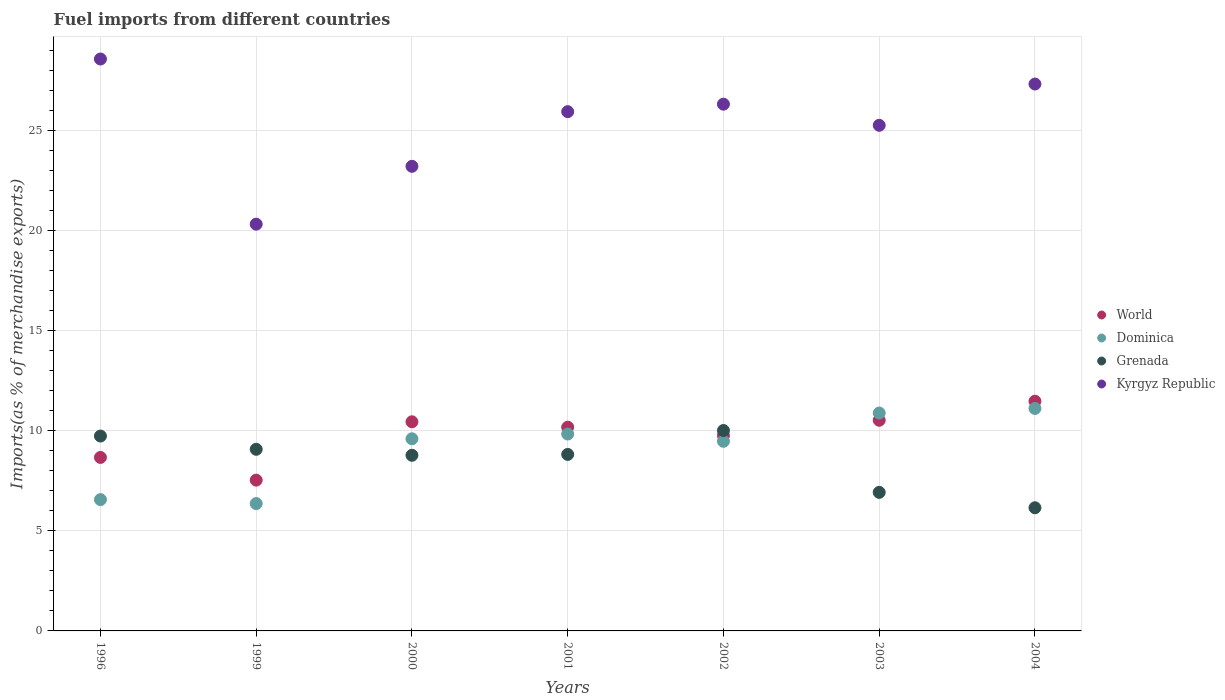Is the number of dotlines equal to the number of legend labels?
Provide a short and direct response. Yes. What is the percentage of imports to different countries in Dominica in 1996?
Provide a succinct answer. 6.56. Across all years, what is the maximum percentage of imports to different countries in World?
Your answer should be compact. 11.48. Across all years, what is the minimum percentage of imports to different countries in Grenada?
Offer a terse response. 6.15. In which year was the percentage of imports to different countries in Dominica minimum?
Give a very brief answer. 1999. What is the total percentage of imports to different countries in World in the graph?
Keep it short and to the point. 68.59. What is the difference between the percentage of imports to different countries in Kyrgyz Republic in 2001 and that in 2002?
Provide a succinct answer. -0.37. What is the difference between the percentage of imports to different countries in Kyrgyz Republic in 2003 and the percentage of imports to different countries in Grenada in 2001?
Offer a very short reply. 16.44. What is the average percentage of imports to different countries in Kyrgyz Republic per year?
Keep it short and to the point. 25.28. In the year 2001, what is the difference between the percentage of imports to different countries in Kyrgyz Republic and percentage of imports to different countries in World?
Give a very brief answer. 15.76. In how many years, is the percentage of imports to different countries in Kyrgyz Republic greater than 16 %?
Your answer should be compact. 7. What is the ratio of the percentage of imports to different countries in Dominica in 2001 to that in 2004?
Your answer should be compact. 0.89. What is the difference between the highest and the second highest percentage of imports to different countries in Kyrgyz Republic?
Give a very brief answer. 1.25. What is the difference between the highest and the lowest percentage of imports to different countries in World?
Give a very brief answer. 3.94. In how many years, is the percentage of imports to different countries in Dominica greater than the average percentage of imports to different countries in Dominica taken over all years?
Offer a very short reply. 5. Is it the case that in every year, the sum of the percentage of imports to different countries in Kyrgyz Republic and percentage of imports to different countries in World  is greater than the sum of percentage of imports to different countries in Dominica and percentage of imports to different countries in Grenada?
Offer a very short reply. Yes. Is it the case that in every year, the sum of the percentage of imports to different countries in Dominica and percentage of imports to different countries in Grenada  is greater than the percentage of imports to different countries in Kyrgyz Republic?
Make the answer very short. No. How many dotlines are there?
Keep it short and to the point. 4. How many years are there in the graph?
Provide a short and direct response. 7. Are the values on the major ticks of Y-axis written in scientific E-notation?
Provide a short and direct response. No. How many legend labels are there?
Your response must be concise. 4. What is the title of the graph?
Provide a succinct answer. Fuel imports from different countries. What is the label or title of the X-axis?
Make the answer very short. Years. What is the label or title of the Y-axis?
Keep it short and to the point. Imports(as % of merchandise exports). What is the Imports(as % of merchandise exports) in World in 1996?
Keep it short and to the point. 8.67. What is the Imports(as % of merchandise exports) in Dominica in 1996?
Your answer should be very brief. 6.56. What is the Imports(as % of merchandise exports) in Grenada in 1996?
Keep it short and to the point. 9.74. What is the Imports(as % of merchandise exports) of Kyrgyz Republic in 1996?
Ensure brevity in your answer.  28.58. What is the Imports(as % of merchandise exports) of World in 1999?
Your response must be concise. 7.53. What is the Imports(as % of merchandise exports) in Dominica in 1999?
Your answer should be very brief. 6.36. What is the Imports(as % of merchandise exports) of Grenada in 1999?
Provide a succinct answer. 9.08. What is the Imports(as % of merchandise exports) of Kyrgyz Republic in 1999?
Keep it short and to the point. 20.32. What is the Imports(as % of merchandise exports) in World in 2000?
Your answer should be compact. 10.45. What is the Imports(as % of merchandise exports) of Dominica in 2000?
Give a very brief answer. 9.6. What is the Imports(as % of merchandise exports) in Grenada in 2000?
Make the answer very short. 8.78. What is the Imports(as % of merchandise exports) of Kyrgyz Republic in 2000?
Offer a very short reply. 23.21. What is the Imports(as % of merchandise exports) of World in 2001?
Offer a terse response. 10.18. What is the Imports(as % of merchandise exports) in Dominica in 2001?
Offer a very short reply. 9.84. What is the Imports(as % of merchandise exports) in Grenada in 2001?
Give a very brief answer. 8.82. What is the Imports(as % of merchandise exports) of Kyrgyz Republic in 2001?
Your answer should be compact. 25.94. What is the Imports(as % of merchandise exports) in World in 2002?
Give a very brief answer. 9.76. What is the Imports(as % of merchandise exports) in Dominica in 2002?
Offer a very short reply. 9.48. What is the Imports(as % of merchandise exports) in Grenada in 2002?
Provide a short and direct response. 10.01. What is the Imports(as % of merchandise exports) of Kyrgyz Republic in 2002?
Provide a short and direct response. 26.32. What is the Imports(as % of merchandise exports) in World in 2003?
Make the answer very short. 10.53. What is the Imports(as % of merchandise exports) of Dominica in 2003?
Provide a succinct answer. 10.89. What is the Imports(as % of merchandise exports) of Grenada in 2003?
Provide a succinct answer. 6.92. What is the Imports(as % of merchandise exports) in Kyrgyz Republic in 2003?
Provide a short and direct response. 25.26. What is the Imports(as % of merchandise exports) of World in 2004?
Your answer should be compact. 11.48. What is the Imports(as % of merchandise exports) in Dominica in 2004?
Your answer should be compact. 11.12. What is the Imports(as % of merchandise exports) of Grenada in 2004?
Ensure brevity in your answer.  6.15. What is the Imports(as % of merchandise exports) in Kyrgyz Republic in 2004?
Offer a terse response. 27.33. Across all years, what is the maximum Imports(as % of merchandise exports) of World?
Provide a short and direct response. 11.48. Across all years, what is the maximum Imports(as % of merchandise exports) of Dominica?
Provide a short and direct response. 11.12. Across all years, what is the maximum Imports(as % of merchandise exports) of Grenada?
Your answer should be compact. 10.01. Across all years, what is the maximum Imports(as % of merchandise exports) in Kyrgyz Republic?
Your answer should be very brief. 28.58. Across all years, what is the minimum Imports(as % of merchandise exports) of World?
Offer a terse response. 7.53. Across all years, what is the minimum Imports(as % of merchandise exports) of Dominica?
Your response must be concise. 6.36. Across all years, what is the minimum Imports(as % of merchandise exports) of Grenada?
Offer a terse response. 6.15. Across all years, what is the minimum Imports(as % of merchandise exports) of Kyrgyz Republic?
Make the answer very short. 20.32. What is the total Imports(as % of merchandise exports) of World in the graph?
Keep it short and to the point. 68.59. What is the total Imports(as % of merchandise exports) of Dominica in the graph?
Make the answer very short. 63.84. What is the total Imports(as % of merchandise exports) in Grenada in the graph?
Your answer should be very brief. 59.5. What is the total Imports(as % of merchandise exports) in Kyrgyz Republic in the graph?
Give a very brief answer. 176.96. What is the difference between the Imports(as % of merchandise exports) in World in 1996 and that in 1999?
Your answer should be very brief. 1.14. What is the difference between the Imports(as % of merchandise exports) in Dominica in 1996 and that in 1999?
Keep it short and to the point. 0.2. What is the difference between the Imports(as % of merchandise exports) of Grenada in 1996 and that in 1999?
Keep it short and to the point. 0.66. What is the difference between the Imports(as % of merchandise exports) of Kyrgyz Republic in 1996 and that in 1999?
Your response must be concise. 8.25. What is the difference between the Imports(as % of merchandise exports) in World in 1996 and that in 2000?
Ensure brevity in your answer.  -1.78. What is the difference between the Imports(as % of merchandise exports) of Dominica in 1996 and that in 2000?
Your response must be concise. -3.04. What is the difference between the Imports(as % of merchandise exports) of Grenada in 1996 and that in 2000?
Your response must be concise. 0.96. What is the difference between the Imports(as % of merchandise exports) of Kyrgyz Republic in 1996 and that in 2000?
Make the answer very short. 5.36. What is the difference between the Imports(as % of merchandise exports) of World in 1996 and that in 2001?
Offer a very short reply. -1.51. What is the difference between the Imports(as % of merchandise exports) of Dominica in 1996 and that in 2001?
Make the answer very short. -3.28. What is the difference between the Imports(as % of merchandise exports) of Grenada in 1996 and that in 2001?
Your response must be concise. 0.92. What is the difference between the Imports(as % of merchandise exports) of Kyrgyz Republic in 1996 and that in 2001?
Make the answer very short. 2.63. What is the difference between the Imports(as % of merchandise exports) of World in 1996 and that in 2002?
Your response must be concise. -1.09. What is the difference between the Imports(as % of merchandise exports) of Dominica in 1996 and that in 2002?
Your answer should be compact. -2.92. What is the difference between the Imports(as % of merchandise exports) in Grenada in 1996 and that in 2002?
Your response must be concise. -0.28. What is the difference between the Imports(as % of merchandise exports) in Kyrgyz Republic in 1996 and that in 2002?
Provide a succinct answer. 2.26. What is the difference between the Imports(as % of merchandise exports) of World in 1996 and that in 2003?
Offer a very short reply. -1.86. What is the difference between the Imports(as % of merchandise exports) in Dominica in 1996 and that in 2003?
Ensure brevity in your answer.  -4.33. What is the difference between the Imports(as % of merchandise exports) of Grenada in 1996 and that in 2003?
Your answer should be very brief. 2.81. What is the difference between the Imports(as % of merchandise exports) of Kyrgyz Republic in 1996 and that in 2003?
Your answer should be compact. 3.31. What is the difference between the Imports(as % of merchandise exports) in World in 1996 and that in 2004?
Provide a succinct answer. -2.81. What is the difference between the Imports(as % of merchandise exports) of Dominica in 1996 and that in 2004?
Make the answer very short. -4.56. What is the difference between the Imports(as % of merchandise exports) of Grenada in 1996 and that in 2004?
Ensure brevity in your answer.  3.58. What is the difference between the Imports(as % of merchandise exports) in Kyrgyz Republic in 1996 and that in 2004?
Your answer should be very brief. 1.25. What is the difference between the Imports(as % of merchandise exports) of World in 1999 and that in 2000?
Your answer should be compact. -2.91. What is the difference between the Imports(as % of merchandise exports) of Dominica in 1999 and that in 2000?
Provide a succinct answer. -3.24. What is the difference between the Imports(as % of merchandise exports) of Grenada in 1999 and that in 2000?
Offer a terse response. 0.3. What is the difference between the Imports(as % of merchandise exports) in Kyrgyz Republic in 1999 and that in 2000?
Your answer should be compact. -2.89. What is the difference between the Imports(as % of merchandise exports) of World in 1999 and that in 2001?
Ensure brevity in your answer.  -2.65. What is the difference between the Imports(as % of merchandise exports) of Dominica in 1999 and that in 2001?
Your answer should be compact. -3.47. What is the difference between the Imports(as % of merchandise exports) of Grenada in 1999 and that in 2001?
Give a very brief answer. 0.26. What is the difference between the Imports(as % of merchandise exports) in Kyrgyz Republic in 1999 and that in 2001?
Give a very brief answer. -5.62. What is the difference between the Imports(as % of merchandise exports) in World in 1999 and that in 2002?
Your response must be concise. -2.23. What is the difference between the Imports(as % of merchandise exports) of Dominica in 1999 and that in 2002?
Your answer should be very brief. -3.11. What is the difference between the Imports(as % of merchandise exports) in Grenada in 1999 and that in 2002?
Make the answer very short. -0.94. What is the difference between the Imports(as % of merchandise exports) of Kyrgyz Republic in 1999 and that in 2002?
Ensure brevity in your answer.  -6. What is the difference between the Imports(as % of merchandise exports) of World in 1999 and that in 2003?
Your response must be concise. -2.99. What is the difference between the Imports(as % of merchandise exports) in Dominica in 1999 and that in 2003?
Provide a short and direct response. -4.52. What is the difference between the Imports(as % of merchandise exports) of Grenada in 1999 and that in 2003?
Your answer should be very brief. 2.15. What is the difference between the Imports(as % of merchandise exports) in Kyrgyz Republic in 1999 and that in 2003?
Offer a terse response. -4.94. What is the difference between the Imports(as % of merchandise exports) in World in 1999 and that in 2004?
Give a very brief answer. -3.94. What is the difference between the Imports(as % of merchandise exports) of Dominica in 1999 and that in 2004?
Make the answer very short. -4.75. What is the difference between the Imports(as % of merchandise exports) in Grenada in 1999 and that in 2004?
Your answer should be very brief. 2.92. What is the difference between the Imports(as % of merchandise exports) in Kyrgyz Republic in 1999 and that in 2004?
Offer a very short reply. -7. What is the difference between the Imports(as % of merchandise exports) of World in 2000 and that in 2001?
Offer a very short reply. 0.27. What is the difference between the Imports(as % of merchandise exports) in Dominica in 2000 and that in 2001?
Keep it short and to the point. -0.24. What is the difference between the Imports(as % of merchandise exports) of Grenada in 2000 and that in 2001?
Make the answer very short. -0.04. What is the difference between the Imports(as % of merchandise exports) in Kyrgyz Republic in 2000 and that in 2001?
Keep it short and to the point. -2.73. What is the difference between the Imports(as % of merchandise exports) of World in 2000 and that in 2002?
Offer a terse response. 0.69. What is the difference between the Imports(as % of merchandise exports) in Dominica in 2000 and that in 2002?
Offer a terse response. 0.13. What is the difference between the Imports(as % of merchandise exports) of Grenada in 2000 and that in 2002?
Give a very brief answer. -1.24. What is the difference between the Imports(as % of merchandise exports) in Kyrgyz Republic in 2000 and that in 2002?
Your answer should be compact. -3.1. What is the difference between the Imports(as % of merchandise exports) of World in 2000 and that in 2003?
Give a very brief answer. -0.08. What is the difference between the Imports(as % of merchandise exports) of Dominica in 2000 and that in 2003?
Keep it short and to the point. -1.29. What is the difference between the Imports(as % of merchandise exports) in Grenada in 2000 and that in 2003?
Offer a terse response. 1.85. What is the difference between the Imports(as % of merchandise exports) of Kyrgyz Republic in 2000 and that in 2003?
Ensure brevity in your answer.  -2.05. What is the difference between the Imports(as % of merchandise exports) of World in 2000 and that in 2004?
Ensure brevity in your answer.  -1.03. What is the difference between the Imports(as % of merchandise exports) in Dominica in 2000 and that in 2004?
Offer a terse response. -1.52. What is the difference between the Imports(as % of merchandise exports) of Grenada in 2000 and that in 2004?
Make the answer very short. 2.62. What is the difference between the Imports(as % of merchandise exports) in Kyrgyz Republic in 2000 and that in 2004?
Offer a very short reply. -4.11. What is the difference between the Imports(as % of merchandise exports) of World in 2001 and that in 2002?
Your answer should be very brief. 0.42. What is the difference between the Imports(as % of merchandise exports) in Dominica in 2001 and that in 2002?
Provide a short and direct response. 0.36. What is the difference between the Imports(as % of merchandise exports) of Grenada in 2001 and that in 2002?
Keep it short and to the point. -1.19. What is the difference between the Imports(as % of merchandise exports) of Kyrgyz Republic in 2001 and that in 2002?
Offer a very short reply. -0.37. What is the difference between the Imports(as % of merchandise exports) of World in 2001 and that in 2003?
Provide a short and direct response. -0.35. What is the difference between the Imports(as % of merchandise exports) in Dominica in 2001 and that in 2003?
Offer a terse response. -1.05. What is the difference between the Imports(as % of merchandise exports) of Grenada in 2001 and that in 2003?
Offer a very short reply. 1.9. What is the difference between the Imports(as % of merchandise exports) in Kyrgyz Republic in 2001 and that in 2003?
Your answer should be compact. 0.68. What is the difference between the Imports(as % of merchandise exports) in World in 2001 and that in 2004?
Give a very brief answer. -1.3. What is the difference between the Imports(as % of merchandise exports) of Dominica in 2001 and that in 2004?
Make the answer very short. -1.28. What is the difference between the Imports(as % of merchandise exports) of Grenada in 2001 and that in 2004?
Your answer should be compact. 2.66. What is the difference between the Imports(as % of merchandise exports) in Kyrgyz Republic in 2001 and that in 2004?
Your answer should be very brief. -1.38. What is the difference between the Imports(as % of merchandise exports) of World in 2002 and that in 2003?
Make the answer very short. -0.77. What is the difference between the Imports(as % of merchandise exports) of Dominica in 2002 and that in 2003?
Offer a terse response. -1.41. What is the difference between the Imports(as % of merchandise exports) of Grenada in 2002 and that in 2003?
Your response must be concise. 3.09. What is the difference between the Imports(as % of merchandise exports) of Kyrgyz Republic in 2002 and that in 2003?
Your answer should be very brief. 1.06. What is the difference between the Imports(as % of merchandise exports) of World in 2002 and that in 2004?
Your answer should be very brief. -1.72. What is the difference between the Imports(as % of merchandise exports) in Dominica in 2002 and that in 2004?
Your answer should be very brief. -1.64. What is the difference between the Imports(as % of merchandise exports) in Grenada in 2002 and that in 2004?
Your response must be concise. 3.86. What is the difference between the Imports(as % of merchandise exports) of Kyrgyz Republic in 2002 and that in 2004?
Ensure brevity in your answer.  -1.01. What is the difference between the Imports(as % of merchandise exports) in World in 2003 and that in 2004?
Your answer should be very brief. -0.95. What is the difference between the Imports(as % of merchandise exports) in Dominica in 2003 and that in 2004?
Keep it short and to the point. -0.23. What is the difference between the Imports(as % of merchandise exports) in Grenada in 2003 and that in 2004?
Offer a terse response. 0.77. What is the difference between the Imports(as % of merchandise exports) in Kyrgyz Republic in 2003 and that in 2004?
Make the answer very short. -2.06. What is the difference between the Imports(as % of merchandise exports) in World in 1996 and the Imports(as % of merchandise exports) in Dominica in 1999?
Give a very brief answer. 2.31. What is the difference between the Imports(as % of merchandise exports) in World in 1996 and the Imports(as % of merchandise exports) in Grenada in 1999?
Offer a terse response. -0.41. What is the difference between the Imports(as % of merchandise exports) of World in 1996 and the Imports(as % of merchandise exports) of Kyrgyz Republic in 1999?
Make the answer very short. -11.65. What is the difference between the Imports(as % of merchandise exports) of Dominica in 1996 and the Imports(as % of merchandise exports) of Grenada in 1999?
Your response must be concise. -2.52. What is the difference between the Imports(as % of merchandise exports) of Dominica in 1996 and the Imports(as % of merchandise exports) of Kyrgyz Republic in 1999?
Offer a terse response. -13.76. What is the difference between the Imports(as % of merchandise exports) of Grenada in 1996 and the Imports(as % of merchandise exports) of Kyrgyz Republic in 1999?
Your answer should be compact. -10.59. What is the difference between the Imports(as % of merchandise exports) in World in 1996 and the Imports(as % of merchandise exports) in Dominica in 2000?
Keep it short and to the point. -0.93. What is the difference between the Imports(as % of merchandise exports) in World in 1996 and the Imports(as % of merchandise exports) in Grenada in 2000?
Ensure brevity in your answer.  -0.11. What is the difference between the Imports(as % of merchandise exports) of World in 1996 and the Imports(as % of merchandise exports) of Kyrgyz Republic in 2000?
Give a very brief answer. -14.54. What is the difference between the Imports(as % of merchandise exports) in Dominica in 1996 and the Imports(as % of merchandise exports) in Grenada in 2000?
Your answer should be compact. -2.22. What is the difference between the Imports(as % of merchandise exports) of Dominica in 1996 and the Imports(as % of merchandise exports) of Kyrgyz Republic in 2000?
Make the answer very short. -16.65. What is the difference between the Imports(as % of merchandise exports) of Grenada in 1996 and the Imports(as % of merchandise exports) of Kyrgyz Republic in 2000?
Offer a very short reply. -13.48. What is the difference between the Imports(as % of merchandise exports) in World in 1996 and the Imports(as % of merchandise exports) in Dominica in 2001?
Provide a succinct answer. -1.17. What is the difference between the Imports(as % of merchandise exports) in World in 1996 and the Imports(as % of merchandise exports) in Grenada in 2001?
Provide a short and direct response. -0.15. What is the difference between the Imports(as % of merchandise exports) in World in 1996 and the Imports(as % of merchandise exports) in Kyrgyz Republic in 2001?
Ensure brevity in your answer.  -17.28. What is the difference between the Imports(as % of merchandise exports) in Dominica in 1996 and the Imports(as % of merchandise exports) in Grenada in 2001?
Your response must be concise. -2.26. What is the difference between the Imports(as % of merchandise exports) of Dominica in 1996 and the Imports(as % of merchandise exports) of Kyrgyz Republic in 2001?
Keep it short and to the point. -19.38. What is the difference between the Imports(as % of merchandise exports) in Grenada in 1996 and the Imports(as % of merchandise exports) in Kyrgyz Republic in 2001?
Ensure brevity in your answer.  -16.21. What is the difference between the Imports(as % of merchandise exports) in World in 1996 and the Imports(as % of merchandise exports) in Dominica in 2002?
Make the answer very short. -0.81. What is the difference between the Imports(as % of merchandise exports) in World in 1996 and the Imports(as % of merchandise exports) in Grenada in 2002?
Make the answer very short. -1.34. What is the difference between the Imports(as % of merchandise exports) of World in 1996 and the Imports(as % of merchandise exports) of Kyrgyz Republic in 2002?
Your answer should be very brief. -17.65. What is the difference between the Imports(as % of merchandise exports) of Dominica in 1996 and the Imports(as % of merchandise exports) of Grenada in 2002?
Make the answer very short. -3.45. What is the difference between the Imports(as % of merchandise exports) in Dominica in 1996 and the Imports(as % of merchandise exports) in Kyrgyz Republic in 2002?
Give a very brief answer. -19.76. What is the difference between the Imports(as % of merchandise exports) of Grenada in 1996 and the Imports(as % of merchandise exports) of Kyrgyz Republic in 2002?
Ensure brevity in your answer.  -16.58. What is the difference between the Imports(as % of merchandise exports) of World in 1996 and the Imports(as % of merchandise exports) of Dominica in 2003?
Your answer should be compact. -2.22. What is the difference between the Imports(as % of merchandise exports) in World in 1996 and the Imports(as % of merchandise exports) in Grenada in 2003?
Make the answer very short. 1.75. What is the difference between the Imports(as % of merchandise exports) in World in 1996 and the Imports(as % of merchandise exports) in Kyrgyz Republic in 2003?
Provide a succinct answer. -16.59. What is the difference between the Imports(as % of merchandise exports) of Dominica in 1996 and the Imports(as % of merchandise exports) of Grenada in 2003?
Give a very brief answer. -0.36. What is the difference between the Imports(as % of merchandise exports) in Dominica in 1996 and the Imports(as % of merchandise exports) in Kyrgyz Republic in 2003?
Provide a succinct answer. -18.7. What is the difference between the Imports(as % of merchandise exports) of Grenada in 1996 and the Imports(as % of merchandise exports) of Kyrgyz Republic in 2003?
Make the answer very short. -15.53. What is the difference between the Imports(as % of merchandise exports) of World in 1996 and the Imports(as % of merchandise exports) of Dominica in 2004?
Offer a very short reply. -2.45. What is the difference between the Imports(as % of merchandise exports) in World in 1996 and the Imports(as % of merchandise exports) in Grenada in 2004?
Make the answer very short. 2.52. What is the difference between the Imports(as % of merchandise exports) in World in 1996 and the Imports(as % of merchandise exports) in Kyrgyz Republic in 2004?
Keep it short and to the point. -18.66. What is the difference between the Imports(as % of merchandise exports) in Dominica in 1996 and the Imports(as % of merchandise exports) in Grenada in 2004?
Offer a very short reply. 0.41. What is the difference between the Imports(as % of merchandise exports) of Dominica in 1996 and the Imports(as % of merchandise exports) of Kyrgyz Republic in 2004?
Provide a short and direct response. -20.77. What is the difference between the Imports(as % of merchandise exports) of Grenada in 1996 and the Imports(as % of merchandise exports) of Kyrgyz Republic in 2004?
Ensure brevity in your answer.  -17.59. What is the difference between the Imports(as % of merchandise exports) of World in 1999 and the Imports(as % of merchandise exports) of Dominica in 2000?
Offer a very short reply. -2.07. What is the difference between the Imports(as % of merchandise exports) in World in 1999 and the Imports(as % of merchandise exports) in Grenada in 2000?
Make the answer very short. -1.24. What is the difference between the Imports(as % of merchandise exports) of World in 1999 and the Imports(as % of merchandise exports) of Kyrgyz Republic in 2000?
Your response must be concise. -15.68. What is the difference between the Imports(as % of merchandise exports) in Dominica in 1999 and the Imports(as % of merchandise exports) in Grenada in 2000?
Provide a short and direct response. -2.41. What is the difference between the Imports(as % of merchandise exports) in Dominica in 1999 and the Imports(as % of merchandise exports) in Kyrgyz Republic in 2000?
Provide a short and direct response. -16.85. What is the difference between the Imports(as % of merchandise exports) in Grenada in 1999 and the Imports(as % of merchandise exports) in Kyrgyz Republic in 2000?
Offer a very short reply. -14.14. What is the difference between the Imports(as % of merchandise exports) of World in 1999 and the Imports(as % of merchandise exports) of Dominica in 2001?
Offer a very short reply. -2.3. What is the difference between the Imports(as % of merchandise exports) of World in 1999 and the Imports(as % of merchandise exports) of Grenada in 2001?
Your response must be concise. -1.28. What is the difference between the Imports(as % of merchandise exports) in World in 1999 and the Imports(as % of merchandise exports) in Kyrgyz Republic in 2001?
Make the answer very short. -18.41. What is the difference between the Imports(as % of merchandise exports) in Dominica in 1999 and the Imports(as % of merchandise exports) in Grenada in 2001?
Your answer should be compact. -2.46. What is the difference between the Imports(as % of merchandise exports) of Dominica in 1999 and the Imports(as % of merchandise exports) of Kyrgyz Republic in 2001?
Your answer should be very brief. -19.58. What is the difference between the Imports(as % of merchandise exports) in Grenada in 1999 and the Imports(as % of merchandise exports) in Kyrgyz Republic in 2001?
Give a very brief answer. -16.87. What is the difference between the Imports(as % of merchandise exports) of World in 1999 and the Imports(as % of merchandise exports) of Dominica in 2002?
Your answer should be compact. -1.94. What is the difference between the Imports(as % of merchandise exports) in World in 1999 and the Imports(as % of merchandise exports) in Grenada in 2002?
Keep it short and to the point. -2.48. What is the difference between the Imports(as % of merchandise exports) in World in 1999 and the Imports(as % of merchandise exports) in Kyrgyz Republic in 2002?
Make the answer very short. -18.79. What is the difference between the Imports(as % of merchandise exports) in Dominica in 1999 and the Imports(as % of merchandise exports) in Grenada in 2002?
Provide a succinct answer. -3.65. What is the difference between the Imports(as % of merchandise exports) of Dominica in 1999 and the Imports(as % of merchandise exports) of Kyrgyz Republic in 2002?
Provide a succinct answer. -19.96. What is the difference between the Imports(as % of merchandise exports) in Grenada in 1999 and the Imports(as % of merchandise exports) in Kyrgyz Republic in 2002?
Your answer should be compact. -17.24. What is the difference between the Imports(as % of merchandise exports) in World in 1999 and the Imports(as % of merchandise exports) in Dominica in 2003?
Your answer should be very brief. -3.35. What is the difference between the Imports(as % of merchandise exports) in World in 1999 and the Imports(as % of merchandise exports) in Grenada in 2003?
Offer a terse response. 0.61. What is the difference between the Imports(as % of merchandise exports) of World in 1999 and the Imports(as % of merchandise exports) of Kyrgyz Republic in 2003?
Make the answer very short. -17.73. What is the difference between the Imports(as % of merchandise exports) of Dominica in 1999 and the Imports(as % of merchandise exports) of Grenada in 2003?
Ensure brevity in your answer.  -0.56. What is the difference between the Imports(as % of merchandise exports) in Dominica in 1999 and the Imports(as % of merchandise exports) in Kyrgyz Republic in 2003?
Give a very brief answer. -18.9. What is the difference between the Imports(as % of merchandise exports) in Grenada in 1999 and the Imports(as % of merchandise exports) in Kyrgyz Republic in 2003?
Your answer should be very brief. -16.19. What is the difference between the Imports(as % of merchandise exports) in World in 1999 and the Imports(as % of merchandise exports) in Dominica in 2004?
Provide a succinct answer. -3.58. What is the difference between the Imports(as % of merchandise exports) in World in 1999 and the Imports(as % of merchandise exports) in Grenada in 2004?
Make the answer very short. 1.38. What is the difference between the Imports(as % of merchandise exports) in World in 1999 and the Imports(as % of merchandise exports) in Kyrgyz Republic in 2004?
Your response must be concise. -19.79. What is the difference between the Imports(as % of merchandise exports) in Dominica in 1999 and the Imports(as % of merchandise exports) in Grenada in 2004?
Provide a short and direct response. 0.21. What is the difference between the Imports(as % of merchandise exports) of Dominica in 1999 and the Imports(as % of merchandise exports) of Kyrgyz Republic in 2004?
Give a very brief answer. -20.96. What is the difference between the Imports(as % of merchandise exports) of Grenada in 1999 and the Imports(as % of merchandise exports) of Kyrgyz Republic in 2004?
Your response must be concise. -18.25. What is the difference between the Imports(as % of merchandise exports) of World in 2000 and the Imports(as % of merchandise exports) of Dominica in 2001?
Provide a succinct answer. 0.61. What is the difference between the Imports(as % of merchandise exports) in World in 2000 and the Imports(as % of merchandise exports) in Grenada in 2001?
Ensure brevity in your answer.  1.63. What is the difference between the Imports(as % of merchandise exports) of World in 2000 and the Imports(as % of merchandise exports) of Kyrgyz Republic in 2001?
Provide a short and direct response. -15.5. What is the difference between the Imports(as % of merchandise exports) in Dominica in 2000 and the Imports(as % of merchandise exports) in Grenada in 2001?
Give a very brief answer. 0.78. What is the difference between the Imports(as % of merchandise exports) of Dominica in 2000 and the Imports(as % of merchandise exports) of Kyrgyz Republic in 2001?
Offer a very short reply. -16.34. What is the difference between the Imports(as % of merchandise exports) in Grenada in 2000 and the Imports(as % of merchandise exports) in Kyrgyz Republic in 2001?
Give a very brief answer. -17.17. What is the difference between the Imports(as % of merchandise exports) in World in 2000 and the Imports(as % of merchandise exports) in Dominica in 2002?
Provide a short and direct response. 0.97. What is the difference between the Imports(as % of merchandise exports) in World in 2000 and the Imports(as % of merchandise exports) in Grenada in 2002?
Ensure brevity in your answer.  0.43. What is the difference between the Imports(as % of merchandise exports) of World in 2000 and the Imports(as % of merchandise exports) of Kyrgyz Republic in 2002?
Your answer should be very brief. -15.87. What is the difference between the Imports(as % of merchandise exports) of Dominica in 2000 and the Imports(as % of merchandise exports) of Grenada in 2002?
Provide a succinct answer. -0.41. What is the difference between the Imports(as % of merchandise exports) in Dominica in 2000 and the Imports(as % of merchandise exports) in Kyrgyz Republic in 2002?
Offer a terse response. -16.72. What is the difference between the Imports(as % of merchandise exports) of Grenada in 2000 and the Imports(as % of merchandise exports) of Kyrgyz Republic in 2002?
Offer a terse response. -17.54. What is the difference between the Imports(as % of merchandise exports) of World in 2000 and the Imports(as % of merchandise exports) of Dominica in 2003?
Offer a terse response. -0.44. What is the difference between the Imports(as % of merchandise exports) of World in 2000 and the Imports(as % of merchandise exports) of Grenada in 2003?
Keep it short and to the point. 3.53. What is the difference between the Imports(as % of merchandise exports) of World in 2000 and the Imports(as % of merchandise exports) of Kyrgyz Republic in 2003?
Ensure brevity in your answer.  -14.81. What is the difference between the Imports(as % of merchandise exports) of Dominica in 2000 and the Imports(as % of merchandise exports) of Grenada in 2003?
Offer a terse response. 2.68. What is the difference between the Imports(as % of merchandise exports) in Dominica in 2000 and the Imports(as % of merchandise exports) in Kyrgyz Republic in 2003?
Your answer should be compact. -15.66. What is the difference between the Imports(as % of merchandise exports) in Grenada in 2000 and the Imports(as % of merchandise exports) in Kyrgyz Republic in 2003?
Provide a short and direct response. -16.49. What is the difference between the Imports(as % of merchandise exports) in World in 2000 and the Imports(as % of merchandise exports) in Dominica in 2004?
Offer a terse response. -0.67. What is the difference between the Imports(as % of merchandise exports) in World in 2000 and the Imports(as % of merchandise exports) in Grenada in 2004?
Your answer should be very brief. 4.29. What is the difference between the Imports(as % of merchandise exports) in World in 2000 and the Imports(as % of merchandise exports) in Kyrgyz Republic in 2004?
Offer a terse response. -16.88. What is the difference between the Imports(as % of merchandise exports) in Dominica in 2000 and the Imports(as % of merchandise exports) in Grenada in 2004?
Your response must be concise. 3.45. What is the difference between the Imports(as % of merchandise exports) of Dominica in 2000 and the Imports(as % of merchandise exports) of Kyrgyz Republic in 2004?
Offer a terse response. -17.73. What is the difference between the Imports(as % of merchandise exports) in Grenada in 2000 and the Imports(as % of merchandise exports) in Kyrgyz Republic in 2004?
Provide a succinct answer. -18.55. What is the difference between the Imports(as % of merchandise exports) of World in 2001 and the Imports(as % of merchandise exports) of Dominica in 2002?
Offer a terse response. 0.7. What is the difference between the Imports(as % of merchandise exports) of World in 2001 and the Imports(as % of merchandise exports) of Grenada in 2002?
Provide a short and direct response. 0.17. What is the difference between the Imports(as % of merchandise exports) in World in 2001 and the Imports(as % of merchandise exports) in Kyrgyz Republic in 2002?
Provide a short and direct response. -16.14. What is the difference between the Imports(as % of merchandise exports) of Dominica in 2001 and the Imports(as % of merchandise exports) of Grenada in 2002?
Your answer should be very brief. -0.18. What is the difference between the Imports(as % of merchandise exports) in Dominica in 2001 and the Imports(as % of merchandise exports) in Kyrgyz Republic in 2002?
Offer a terse response. -16.48. What is the difference between the Imports(as % of merchandise exports) in Grenada in 2001 and the Imports(as % of merchandise exports) in Kyrgyz Republic in 2002?
Offer a terse response. -17.5. What is the difference between the Imports(as % of merchandise exports) in World in 2001 and the Imports(as % of merchandise exports) in Dominica in 2003?
Offer a terse response. -0.71. What is the difference between the Imports(as % of merchandise exports) of World in 2001 and the Imports(as % of merchandise exports) of Grenada in 2003?
Offer a very short reply. 3.26. What is the difference between the Imports(as % of merchandise exports) of World in 2001 and the Imports(as % of merchandise exports) of Kyrgyz Republic in 2003?
Ensure brevity in your answer.  -15.08. What is the difference between the Imports(as % of merchandise exports) in Dominica in 2001 and the Imports(as % of merchandise exports) in Grenada in 2003?
Your response must be concise. 2.91. What is the difference between the Imports(as % of merchandise exports) of Dominica in 2001 and the Imports(as % of merchandise exports) of Kyrgyz Republic in 2003?
Provide a succinct answer. -15.43. What is the difference between the Imports(as % of merchandise exports) of Grenada in 2001 and the Imports(as % of merchandise exports) of Kyrgyz Republic in 2003?
Offer a very short reply. -16.44. What is the difference between the Imports(as % of merchandise exports) in World in 2001 and the Imports(as % of merchandise exports) in Dominica in 2004?
Provide a short and direct response. -0.94. What is the difference between the Imports(as % of merchandise exports) in World in 2001 and the Imports(as % of merchandise exports) in Grenada in 2004?
Your answer should be compact. 4.03. What is the difference between the Imports(as % of merchandise exports) in World in 2001 and the Imports(as % of merchandise exports) in Kyrgyz Republic in 2004?
Offer a terse response. -17.15. What is the difference between the Imports(as % of merchandise exports) in Dominica in 2001 and the Imports(as % of merchandise exports) in Grenada in 2004?
Your response must be concise. 3.68. What is the difference between the Imports(as % of merchandise exports) of Dominica in 2001 and the Imports(as % of merchandise exports) of Kyrgyz Republic in 2004?
Make the answer very short. -17.49. What is the difference between the Imports(as % of merchandise exports) in Grenada in 2001 and the Imports(as % of merchandise exports) in Kyrgyz Republic in 2004?
Provide a succinct answer. -18.51. What is the difference between the Imports(as % of merchandise exports) in World in 2002 and the Imports(as % of merchandise exports) in Dominica in 2003?
Offer a terse response. -1.13. What is the difference between the Imports(as % of merchandise exports) of World in 2002 and the Imports(as % of merchandise exports) of Grenada in 2003?
Provide a short and direct response. 2.84. What is the difference between the Imports(as % of merchandise exports) in World in 2002 and the Imports(as % of merchandise exports) in Kyrgyz Republic in 2003?
Your answer should be very brief. -15.5. What is the difference between the Imports(as % of merchandise exports) of Dominica in 2002 and the Imports(as % of merchandise exports) of Grenada in 2003?
Your response must be concise. 2.55. What is the difference between the Imports(as % of merchandise exports) in Dominica in 2002 and the Imports(as % of merchandise exports) in Kyrgyz Republic in 2003?
Provide a short and direct response. -15.79. What is the difference between the Imports(as % of merchandise exports) of Grenada in 2002 and the Imports(as % of merchandise exports) of Kyrgyz Republic in 2003?
Keep it short and to the point. -15.25. What is the difference between the Imports(as % of merchandise exports) in World in 2002 and the Imports(as % of merchandise exports) in Dominica in 2004?
Your response must be concise. -1.35. What is the difference between the Imports(as % of merchandise exports) in World in 2002 and the Imports(as % of merchandise exports) in Grenada in 2004?
Give a very brief answer. 3.61. What is the difference between the Imports(as % of merchandise exports) in World in 2002 and the Imports(as % of merchandise exports) in Kyrgyz Republic in 2004?
Your response must be concise. -17.57. What is the difference between the Imports(as % of merchandise exports) in Dominica in 2002 and the Imports(as % of merchandise exports) in Grenada in 2004?
Provide a succinct answer. 3.32. What is the difference between the Imports(as % of merchandise exports) of Dominica in 2002 and the Imports(as % of merchandise exports) of Kyrgyz Republic in 2004?
Your answer should be very brief. -17.85. What is the difference between the Imports(as % of merchandise exports) in Grenada in 2002 and the Imports(as % of merchandise exports) in Kyrgyz Republic in 2004?
Provide a short and direct response. -17.31. What is the difference between the Imports(as % of merchandise exports) of World in 2003 and the Imports(as % of merchandise exports) of Dominica in 2004?
Provide a short and direct response. -0.59. What is the difference between the Imports(as % of merchandise exports) of World in 2003 and the Imports(as % of merchandise exports) of Grenada in 2004?
Your response must be concise. 4.37. What is the difference between the Imports(as % of merchandise exports) in World in 2003 and the Imports(as % of merchandise exports) in Kyrgyz Republic in 2004?
Keep it short and to the point. -16.8. What is the difference between the Imports(as % of merchandise exports) in Dominica in 2003 and the Imports(as % of merchandise exports) in Grenada in 2004?
Offer a very short reply. 4.73. What is the difference between the Imports(as % of merchandise exports) in Dominica in 2003 and the Imports(as % of merchandise exports) in Kyrgyz Republic in 2004?
Your answer should be compact. -16.44. What is the difference between the Imports(as % of merchandise exports) of Grenada in 2003 and the Imports(as % of merchandise exports) of Kyrgyz Republic in 2004?
Provide a short and direct response. -20.4. What is the average Imports(as % of merchandise exports) in World per year?
Give a very brief answer. 9.8. What is the average Imports(as % of merchandise exports) of Dominica per year?
Keep it short and to the point. 9.12. What is the average Imports(as % of merchandise exports) in Grenada per year?
Give a very brief answer. 8.5. What is the average Imports(as % of merchandise exports) in Kyrgyz Republic per year?
Provide a succinct answer. 25.28. In the year 1996, what is the difference between the Imports(as % of merchandise exports) of World and Imports(as % of merchandise exports) of Dominica?
Provide a short and direct response. 2.11. In the year 1996, what is the difference between the Imports(as % of merchandise exports) in World and Imports(as % of merchandise exports) in Grenada?
Your response must be concise. -1.07. In the year 1996, what is the difference between the Imports(as % of merchandise exports) of World and Imports(as % of merchandise exports) of Kyrgyz Republic?
Offer a very short reply. -19.91. In the year 1996, what is the difference between the Imports(as % of merchandise exports) in Dominica and Imports(as % of merchandise exports) in Grenada?
Your answer should be compact. -3.18. In the year 1996, what is the difference between the Imports(as % of merchandise exports) in Dominica and Imports(as % of merchandise exports) in Kyrgyz Republic?
Offer a terse response. -22.02. In the year 1996, what is the difference between the Imports(as % of merchandise exports) of Grenada and Imports(as % of merchandise exports) of Kyrgyz Republic?
Offer a very short reply. -18.84. In the year 1999, what is the difference between the Imports(as % of merchandise exports) of World and Imports(as % of merchandise exports) of Dominica?
Give a very brief answer. 1.17. In the year 1999, what is the difference between the Imports(as % of merchandise exports) of World and Imports(as % of merchandise exports) of Grenada?
Keep it short and to the point. -1.54. In the year 1999, what is the difference between the Imports(as % of merchandise exports) in World and Imports(as % of merchandise exports) in Kyrgyz Republic?
Your answer should be compact. -12.79. In the year 1999, what is the difference between the Imports(as % of merchandise exports) of Dominica and Imports(as % of merchandise exports) of Grenada?
Keep it short and to the point. -2.71. In the year 1999, what is the difference between the Imports(as % of merchandise exports) of Dominica and Imports(as % of merchandise exports) of Kyrgyz Republic?
Your response must be concise. -13.96. In the year 1999, what is the difference between the Imports(as % of merchandise exports) in Grenada and Imports(as % of merchandise exports) in Kyrgyz Republic?
Ensure brevity in your answer.  -11.25. In the year 2000, what is the difference between the Imports(as % of merchandise exports) of World and Imports(as % of merchandise exports) of Dominica?
Make the answer very short. 0.85. In the year 2000, what is the difference between the Imports(as % of merchandise exports) of World and Imports(as % of merchandise exports) of Grenada?
Provide a short and direct response. 1.67. In the year 2000, what is the difference between the Imports(as % of merchandise exports) in World and Imports(as % of merchandise exports) in Kyrgyz Republic?
Give a very brief answer. -12.77. In the year 2000, what is the difference between the Imports(as % of merchandise exports) in Dominica and Imports(as % of merchandise exports) in Grenada?
Provide a succinct answer. 0.82. In the year 2000, what is the difference between the Imports(as % of merchandise exports) in Dominica and Imports(as % of merchandise exports) in Kyrgyz Republic?
Ensure brevity in your answer.  -13.61. In the year 2000, what is the difference between the Imports(as % of merchandise exports) of Grenada and Imports(as % of merchandise exports) of Kyrgyz Republic?
Your response must be concise. -14.44. In the year 2001, what is the difference between the Imports(as % of merchandise exports) in World and Imports(as % of merchandise exports) in Dominica?
Keep it short and to the point. 0.34. In the year 2001, what is the difference between the Imports(as % of merchandise exports) of World and Imports(as % of merchandise exports) of Grenada?
Make the answer very short. 1.36. In the year 2001, what is the difference between the Imports(as % of merchandise exports) in World and Imports(as % of merchandise exports) in Kyrgyz Republic?
Keep it short and to the point. -15.76. In the year 2001, what is the difference between the Imports(as % of merchandise exports) of Dominica and Imports(as % of merchandise exports) of Grenada?
Your answer should be compact. 1.02. In the year 2001, what is the difference between the Imports(as % of merchandise exports) in Dominica and Imports(as % of merchandise exports) in Kyrgyz Republic?
Make the answer very short. -16.11. In the year 2001, what is the difference between the Imports(as % of merchandise exports) in Grenada and Imports(as % of merchandise exports) in Kyrgyz Republic?
Your answer should be compact. -17.13. In the year 2002, what is the difference between the Imports(as % of merchandise exports) in World and Imports(as % of merchandise exports) in Dominica?
Provide a succinct answer. 0.29. In the year 2002, what is the difference between the Imports(as % of merchandise exports) in World and Imports(as % of merchandise exports) in Grenada?
Offer a terse response. -0.25. In the year 2002, what is the difference between the Imports(as % of merchandise exports) of World and Imports(as % of merchandise exports) of Kyrgyz Republic?
Keep it short and to the point. -16.56. In the year 2002, what is the difference between the Imports(as % of merchandise exports) in Dominica and Imports(as % of merchandise exports) in Grenada?
Ensure brevity in your answer.  -0.54. In the year 2002, what is the difference between the Imports(as % of merchandise exports) in Dominica and Imports(as % of merchandise exports) in Kyrgyz Republic?
Offer a very short reply. -16.84. In the year 2002, what is the difference between the Imports(as % of merchandise exports) of Grenada and Imports(as % of merchandise exports) of Kyrgyz Republic?
Provide a succinct answer. -16.31. In the year 2003, what is the difference between the Imports(as % of merchandise exports) of World and Imports(as % of merchandise exports) of Dominica?
Your answer should be compact. -0.36. In the year 2003, what is the difference between the Imports(as % of merchandise exports) in World and Imports(as % of merchandise exports) in Grenada?
Make the answer very short. 3.6. In the year 2003, what is the difference between the Imports(as % of merchandise exports) of World and Imports(as % of merchandise exports) of Kyrgyz Republic?
Ensure brevity in your answer.  -14.74. In the year 2003, what is the difference between the Imports(as % of merchandise exports) in Dominica and Imports(as % of merchandise exports) in Grenada?
Give a very brief answer. 3.97. In the year 2003, what is the difference between the Imports(as % of merchandise exports) of Dominica and Imports(as % of merchandise exports) of Kyrgyz Republic?
Your response must be concise. -14.38. In the year 2003, what is the difference between the Imports(as % of merchandise exports) in Grenada and Imports(as % of merchandise exports) in Kyrgyz Republic?
Keep it short and to the point. -18.34. In the year 2004, what is the difference between the Imports(as % of merchandise exports) of World and Imports(as % of merchandise exports) of Dominica?
Your answer should be compact. 0.36. In the year 2004, what is the difference between the Imports(as % of merchandise exports) in World and Imports(as % of merchandise exports) in Grenada?
Your response must be concise. 5.32. In the year 2004, what is the difference between the Imports(as % of merchandise exports) in World and Imports(as % of merchandise exports) in Kyrgyz Republic?
Your answer should be very brief. -15.85. In the year 2004, what is the difference between the Imports(as % of merchandise exports) of Dominica and Imports(as % of merchandise exports) of Grenada?
Provide a short and direct response. 4.96. In the year 2004, what is the difference between the Imports(as % of merchandise exports) of Dominica and Imports(as % of merchandise exports) of Kyrgyz Republic?
Keep it short and to the point. -16.21. In the year 2004, what is the difference between the Imports(as % of merchandise exports) of Grenada and Imports(as % of merchandise exports) of Kyrgyz Republic?
Ensure brevity in your answer.  -21.17. What is the ratio of the Imports(as % of merchandise exports) of World in 1996 to that in 1999?
Provide a succinct answer. 1.15. What is the ratio of the Imports(as % of merchandise exports) in Dominica in 1996 to that in 1999?
Offer a very short reply. 1.03. What is the ratio of the Imports(as % of merchandise exports) of Grenada in 1996 to that in 1999?
Offer a terse response. 1.07. What is the ratio of the Imports(as % of merchandise exports) of Kyrgyz Republic in 1996 to that in 1999?
Ensure brevity in your answer.  1.41. What is the ratio of the Imports(as % of merchandise exports) in World in 1996 to that in 2000?
Make the answer very short. 0.83. What is the ratio of the Imports(as % of merchandise exports) of Dominica in 1996 to that in 2000?
Offer a terse response. 0.68. What is the ratio of the Imports(as % of merchandise exports) of Grenada in 1996 to that in 2000?
Provide a succinct answer. 1.11. What is the ratio of the Imports(as % of merchandise exports) in Kyrgyz Republic in 1996 to that in 2000?
Your answer should be compact. 1.23. What is the ratio of the Imports(as % of merchandise exports) in World in 1996 to that in 2001?
Ensure brevity in your answer.  0.85. What is the ratio of the Imports(as % of merchandise exports) of Dominica in 1996 to that in 2001?
Offer a very short reply. 0.67. What is the ratio of the Imports(as % of merchandise exports) in Grenada in 1996 to that in 2001?
Provide a short and direct response. 1.1. What is the ratio of the Imports(as % of merchandise exports) of Kyrgyz Republic in 1996 to that in 2001?
Give a very brief answer. 1.1. What is the ratio of the Imports(as % of merchandise exports) of World in 1996 to that in 2002?
Your response must be concise. 0.89. What is the ratio of the Imports(as % of merchandise exports) of Dominica in 1996 to that in 2002?
Offer a very short reply. 0.69. What is the ratio of the Imports(as % of merchandise exports) of Grenada in 1996 to that in 2002?
Give a very brief answer. 0.97. What is the ratio of the Imports(as % of merchandise exports) in Kyrgyz Republic in 1996 to that in 2002?
Your answer should be very brief. 1.09. What is the ratio of the Imports(as % of merchandise exports) in World in 1996 to that in 2003?
Give a very brief answer. 0.82. What is the ratio of the Imports(as % of merchandise exports) of Dominica in 1996 to that in 2003?
Make the answer very short. 0.6. What is the ratio of the Imports(as % of merchandise exports) of Grenada in 1996 to that in 2003?
Your answer should be compact. 1.41. What is the ratio of the Imports(as % of merchandise exports) of Kyrgyz Republic in 1996 to that in 2003?
Provide a succinct answer. 1.13. What is the ratio of the Imports(as % of merchandise exports) in World in 1996 to that in 2004?
Your answer should be compact. 0.76. What is the ratio of the Imports(as % of merchandise exports) in Dominica in 1996 to that in 2004?
Ensure brevity in your answer.  0.59. What is the ratio of the Imports(as % of merchandise exports) of Grenada in 1996 to that in 2004?
Make the answer very short. 1.58. What is the ratio of the Imports(as % of merchandise exports) of Kyrgyz Republic in 1996 to that in 2004?
Your response must be concise. 1.05. What is the ratio of the Imports(as % of merchandise exports) of World in 1999 to that in 2000?
Your answer should be compact. 0.72. What is the ratio of the Imports(as % of merchandise exports) of Dominica in 1999 to that in 2000?
Keep it short and to the point. 0.66. What is the ratio of the Imports(as % of merchandise exports) in Grenada in 1999 to that in 2000?
Make the answer very short. 1.03. What is the ratio of the Imports(as % of merchandise exports) in Kyrgyz Republic in 1999 to that in 2000?
Your answer should be compact. 0.88. What is the ratio of the Imports(as % of merchandise exports) of World in 1999 to that in 2001?
Offer a very short reply. 0.74. What is the ratio of the Imports(as % of merchandise exports) of Dominica in 1999 to that in 2001?
Give a very brief answer. 0.65. What is the ratio of the Imports(as % of merchandise exports) of Grenada in 1999 to that in 2001?
Make the answer very short. 1.03. What is the ratio of the Imports(as % of merchandise exports) in Kyrgyz Republic in 1999 to that in 2001?
Your answer should be compact. 0.78. What is the ratio of the Imports(as % of merchandise exports) of World in 1999 to that in 2002?
Your answer should be very brief. 0.77. What is the ratio of the Imports(as % of merchandise exports) of Dominica in 1999 to that in 2002?
Your answer should be compact. 0.67. What is the ratio of the Imports(as % of merchandise exports) of Grenada in 1999 to that in 2002?
Offer a very short reply. 0.91. What is the ratio of the Imports(as % of merchandise exports) in Kyrgyz Republic in 1999 to that in 2002?
Your answer should be compact. 0.77. What is the ratio of the Imports(as % of merchandise exports) of World in 1999 to that in 2003?
Your answer should be very brief. 0.72. What is the ratio of the Imports(as % of merchandise exports) of Dominica in 1999 to that in 2003?
Keep it short and to the point. 0.58. What is the ratio of the Imports(as % of merchandise exports) of Grenada in 1999 to that in 2003?
Provide a short and direct response. 1.31. What is the ratio of the Imports(as % of merchandise exports) of Kyrgyz Republic in 1999 to that in 2003?
Provide a succinct answer. 0.8. What is the ratio of the Imports(as % of merchandise exports) of World in 1999 to that in 2004?
Keep it short and to the point. 0.66. What is the ratio of the Imports(as % of merchandise exports) of Dominica in 1999 to that in 2004?
Your answer should be compact. 0.57. What is the ratio of the Imports(as % of merchandise exports) in Grenada in 1999 to that in 2004?
Your answer should be compact. 1.47. What is the ratio of the Imports(as % of merchandise exports) of Kyrgyz Republic in 1999 to that in 2004?
Your answer should be very brief. 0.74. What is the ratio of the Imports(as % of merchandise exports) of World in 2000 to that in 2001?
Ensure brevity in your answer.  1.03. What is the ratio of the Imports(as % of merchandise exports) in Dominica in 2000 to that in 2001?
Offer a terse response. 0.98. What is the ratio of the Imports(as % of merchandise exports) of Grenada in 2000 to that in 2001?
Your response must be concise. 1. What is the ratio of the Imports(as % of merchandise exports) of Kyrgyz Republic in 2000 to that in 2001?
Make the answer very short. 0.89. What is the ratio of the Imports(as % of merchandise exports) in World in 2000 to that in 2002?
Make the answer very short. 1.07. What is the ratio of the Imports(as % of merchandise exports) in Dominica in 2000 to that in 2002?
Offer a terse response. 1.01. What is the ratio of the Imports(as % of merchandise exports) of Grenada in 2000 to that in 2002?
Your response must be concise. 0.88. What is the ratio of the Imports(as % of merchandise exports) in Kyrgyz Republic in 2000 to that in 2002?
Offer a very short reply. 0.88. What is the ratio of the Imports(as % of merchandise exports) in World in 2000 to that in 2003?
Give a very brief answer. 0.99. What is the ratio of the Imports(as % of merchandise exports) in Dominica in 2000 to that in 2003?
Your response must be concise. 0.88. What is the ratio of the Imports(as % of merchandise exports) in Grenada in 2000 to that in 2003?
Your answer should be compact. 1.27. What is the ratio of the Imports(as % of merchandise exports) in Kyrgyz Republic in 2000 to that in 2003?
Offer a very short reply. 0.92. What is the ratio of the Imports(as % of merchandise exports) in World in 2000 to that in 2004?
Ensure brevity in your answer.  0.91. What is the ratio of the Imports(as % of merchandise exports) of Dominica in 2000 to that in 2004?
Offer a very short reply. 0.86. What is the ratio of the Imports(as % of merchandise exports) of Grenada in 2000 to that in 2004?
Your answer should be very brief. 1.43. What is the ratio of the Imports(as % of merchandise exports) in Kyrgyz Republic in 2000 to that in 2004?
Keep it short and to the point. 0.85. What is the ratio of the Imports(as % of merchandise exports) in World in 2001 to that in 2002?
Provide a short and direct response. 1.04. What is the ratio of the Imports(as % of merchandise exports) in Dominica in 2001 to that in 2002?
Ensure brevity in your answer.  1.04. What is the ratio of the Imports(as % of merchandise exports) of Grenada in 2001 to that in 2002?
Your answer should be compact. 0.88. What is the ratio of the Imports(as % of merchandise exports) in Kyrgyz Republic in 2001 to that in 2002?
Ensure brevity in your answer.  0.99. What is the ratio of the Imports(as % of merchandise exports) in World in 2001 to that in 2003?
Make the answer very short. 0.97. What is the ratio of the Imports(as % of merchandise exports) of Dominica in 2001 to that in 2003?
Give a very brief answer. 0.9. What is the ratio of the Imports(as % of merchandise exports) in Grenada in 2001 to that in 2003?
Provide a short and direct response. 1.27. What is the ratio of the Imports(as % of merchandise exports) in World in 2001 to that in 2004?
Ensure brevity in your answer.  0.89. What is the ratio of the Imports(as % of merchandise exports) in Dominica in 2001 to that in 2004?
Your response must be concise. 0.89. What is the ratio of the Imports(as % of merchandise exports) of Grenada in 2001 to that in 2004?
Keep it short and to the point. 1.43. What is the ratio of the Imports(as % of merchandise exports) in Kyrgyz Republic in 2001 to that in 2004?
Ensure brevity in your answer.  0.95. What is the ratio of the Imports(as % of merchandise exports) of World in 2002 to that in 2003?
Keep it short and to the point. 0.93. What is the ratio of the Imports(as % of merchandise exports) of Dominica in 2002 to that in 2003?
Provide a succinct answer. 0.87. What is the ratio of the Imports(as % of merchandise exports) of Grenada in 2002 to that in 2003?
Offer a terse response. 1.45. What is the ratio of the Imports(as % of merchandise exports) of Kyrgyz Republic in 2002 to that in 2003?
Offer a very short reply. 1.04. What is the ratio of the Imports(as % of merchandise exports) of World in 2002 to that in 2004?
Provide a short and direct response. 0.85. What is the ratio of the Imports(as % of merchandise exports) of Dominica in 2002 to that in 2004?
Offer a terse response. 0.85. What is the ratio of the Imports(as % of merchandise exports) in Grenada in 2002 to that in 2004?
Ensure brevity in your answer.  1.63. What is the ratio of the Imports(as % of merchandise exports) in Kyrgyz Republic in 2002 to that in 2004?
Your answer should be very brief. 0.96. What is the ratio of the Imports(as % of merchandise exports) of World in 2003 to that in 2004?
Provide a succinct answer. 0.92. What is the ratio of the Imports(as % of merchandise exports) of Dominica in 2003 to that in 2004?
Keep it short and to the point. 0.98. What is the ratio of the Imports(as % of merchandise exports) of Kyrgyz Republic in 2003 to that in 2004?
Offer a very short reply. 0.92. What is the difference between the highest and the second highest Imports(as % of merchandise exports) of World?
Offer a terse response. 0.95. What is the difference between the highest and the second highest Imports(as % of merchandise exports) in Dominica?
Your answer should be compact. 0.23. What is the difference between the highest and the second highest Imports(as % of merchandise exports) of Grenada?
Make the answer very short. 0.28. What is the difference between the highest and the second highest Imports(as % of merchandise exports) of Kyrgyz Republic?
Make the answer very short. 1.25. What is the difference between the highest and the lowest Imports(as % of merchandise exports) in World?
Make the answer very short. 3.94. What is the difference between the highest and the lowest Imports(as % of merchandise exports) in Dominica?
Give a very brief answer. 4.75. What is the difference between the highest and the lowest Imports(as % of merchandise exports) of Grenada?
Provide a short and direct response. 3.86. What is the difference between the highest and the lowest Imports(as % of merchandise exports) of Kyrgyz Republic?
Keep it short and to the point. 8.25. 